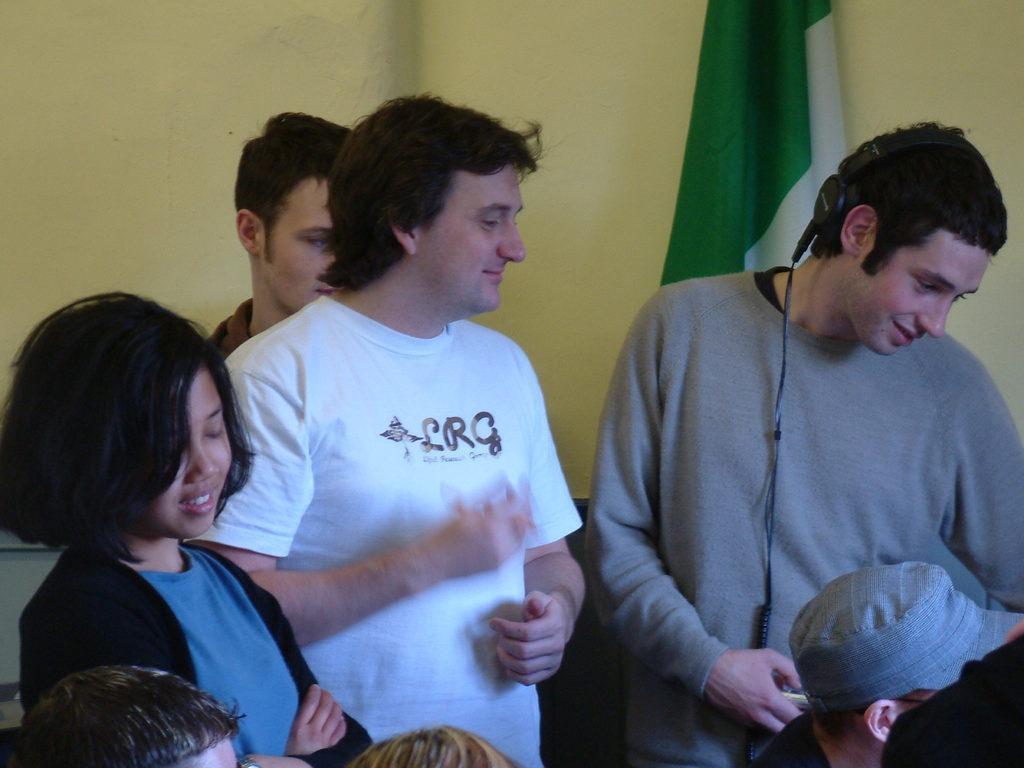How would you summarize this image in a sentence or two? In this picture I can observe some people. Some of them are sitting and some of them are standing. I can observe a flag on the right side which is in green and white color. In the background there is a wall which is in cream color. 